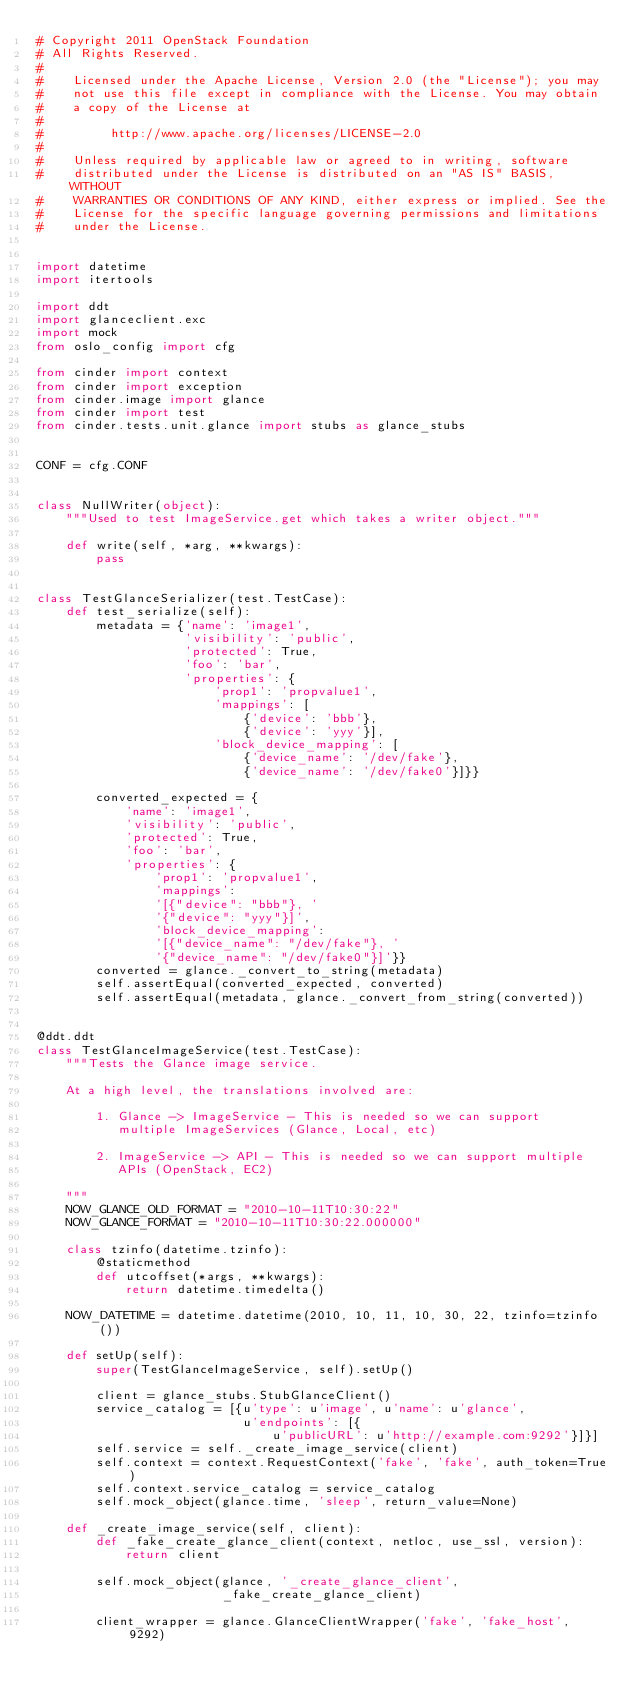<code> <loc_0><loc_0><loc_500><loc_500><_Python_># Copyright 2011 OpenStack Foundation
# All Rights Reserved.
#
#    Licensed under the Apache License, Version 2.0 (the "License"); you may
#    not use this file except in compliance with the License. You may obtain
#    a copy of the License at
#
#         http://www.apache.org/licenses/LICENSE-2.0
#
#    Unless required by applicable law or agreed to in writing, software
#    distributed under the License is distributed on an "AS IS" BASIS, WITHOUT
#    WARRANTIES OR CONDITIONS OF ANY KIND, either express or implied. See the
#    License for the specific language governing permissions and limitations
#    under the License.


import datetime
import itertools

import ddt
import glanceclient.exc
import mock
from oslo_config import cfg

from cinder import context
from cinder import exception
from cinder.image import glance
from cinder import test
from cinder.tests.unit.glance import stubs as glance_stubs


CONF = cfg.CONF


class NullWriter(object):
    """Used to test ImageService.get which takes a writer object."""

    def write(self, *arg, **kwargs):
        pass


class TestGlanceSerializer(test.TestCase):
    def test_serialize(self):
        metadata = {'name': 'image1',
                    'visibility': 'public',
                    'protected': True,
                    'foo': 'bar',
                    'properties': {
                        'prop1': 'propvalue1',
                        'mappings': [
                            {'device': 'bbb'},
                            {'device': 'yyy'}],
                        'block_device_mapping': [
                            {'device_name': '/dev/fake'},
                            {'device_name': '/dev/fake0'}]}}

        converted_expected = {
            'name': 'image1',
            'visibility': 'public',
            'protected': True,
            'foo': 'bar',
            'properties': {
                'prop1': 'propvalue1',
                'mappings':
                '[{"device": "bbb"}, '
                '{"device": "yyy"}]',
                'block_device_mapping':
                '[{"device_name": "/dev/fake"}, '
                '{"device_name": "/dev/fake0"}]'}}
        converted = glance._convert_to_string(metadata)
        self.assertEqual(converted_expected, converted)
        self.assertEqual(metadata, glance._convert_from_string(converted))


@ddt.ddt
class TestGlanceImageService(test.TestCase):
    """Tests the Glance image service.

    At a high level, the translations involved are:

        1. Glance -> ImageService - This is needed so we can support
           multiple ImageServices (Glance, Local, etc)

        2. ImageService -> API - This is needed so we can support multiple
           APIs (OpenStack, EC2)

    """
    NOW_GLANCE_OLD_FORMAT = "2010-10-11T10:30:22"
    NOW_GLANCE_FORMAT = "2010-10-11T10:30:22.000000"

    class tzinfo(datetime.tzinfo):
        @staticmethod
        def utcoffset(*args, **kwargs):
            return datetime.timedelta()

    NOW_DATETIME = datetime.datetime(2010, 10, 11, 10, 30, 22, tzinfo=tzinfo())

    def setUp(self):
        super(TestGlanceImageService, self).setUp()

        client = glance_stubs.StubGlanceClient()
        service_catalog = [{u'type': u'image', u'name': u'glance',
                            u'endpoints': [{
                                u'publicURL': u'http://example.com:9292'}]}]
        self.service = self._create_image_service(client)
        self.context = context.RequestContext('fake', 'fake', auth_token=True)
        self.context.service_catalog = service_catalog
        self.mock_object(glance.time, 'sleep', return_value=None)

    def _create_image_service(self, client):
        def _fake_create_glance_client(context, netloc, use_ssl, version):
            return client

        self.mock_object(glance, '_create_glance_client',
                         _fake_create_glance_client)

        client_wrapper = glance.GlanceClientWrapper('fake', 'fake_host', 9292)</code> 